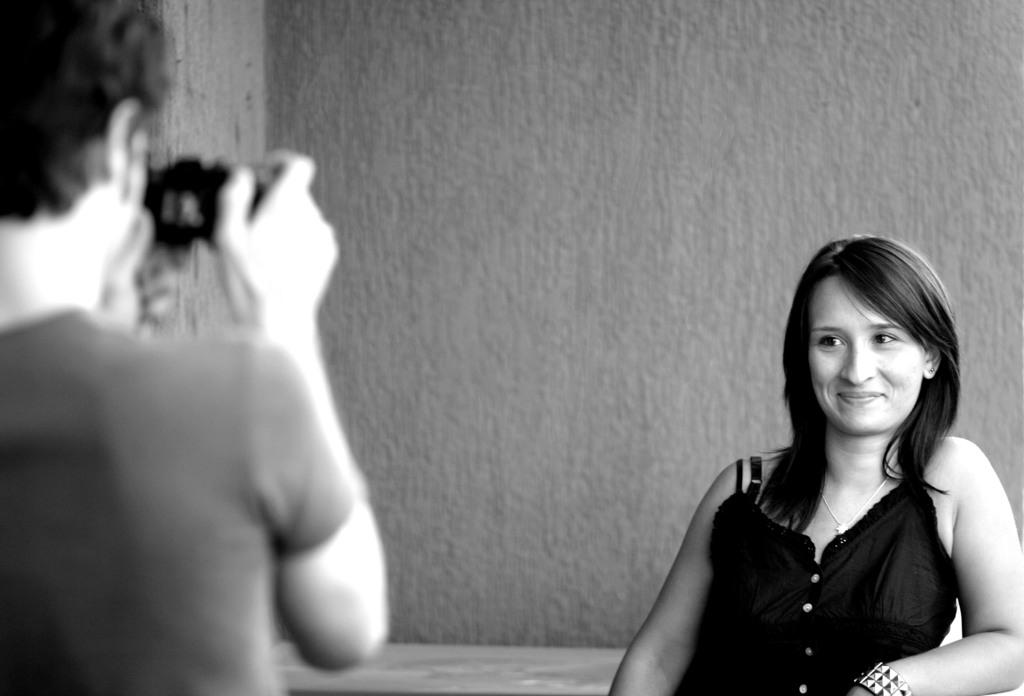What is the color scheme of the image? The image is black and white. How many people are present in the image? There is a man and a woman in the image. What is the man holding in the image? The man is holding a camera. What can be seen in the background of the image? There is a wall visible in the image. How many sisters are present in the image? There is no mention of sisters in the image, as it only features a man and a woman. What type of crate is visible in the image? There is no crate present in the image. 